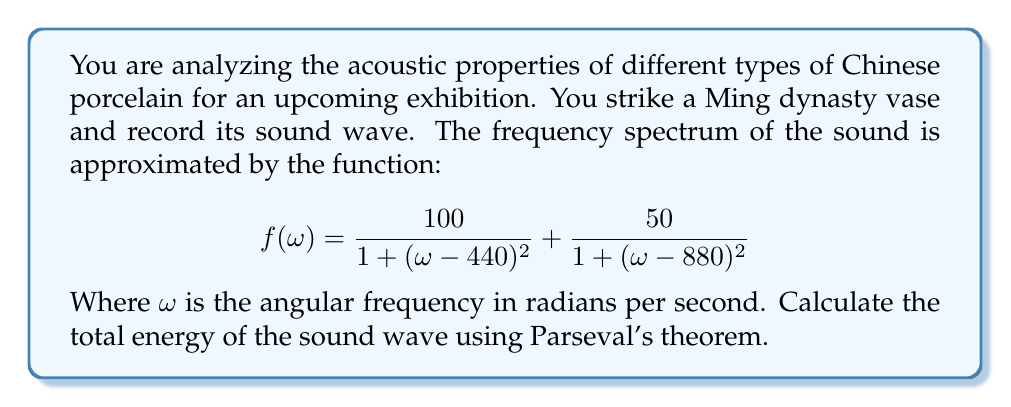Solve this math problem. To solve this problem, we'll use Parseval's theorem, which states that the total energy of a signal is equal to the integral of the squared magnitude of its Fourier transform over all frequencies.

1) The given function $f(\omega)$ represents the frequency spectrum, which is essentially the magnitude of the Fourier transform of the sound wave.

2) According to Parseval's theorem, the total energy $E$ is given by:

   $$E = \frac{1}{2\pi} \int_{-\infty}^{\infty} |f(\omega)|^2 d\omega$$

3) Substituting our function:

   $$E = \frac{1}{2\pi} \int_{-\infty}^{\infty} \left(\frac{100}{1 + (\omega - 440)^2} + \frac{50}{1 + (\omega - 880)^2}\right)^2 d\omega$$

4) Expanding the squared term:

   $$E = \frac{1}{2\pi} \int_{-\infty}^{\infty} \left(\frac{10000}{(1 + (\omega - 440)^2)^2} + \frac{2500}{(1 + (\omega - 880)^2)^2} + \frac{10000}{(1 + (\omega - 440)^2)(1 + (\omega - 880)^2)}\right) d\omega$$

5) This integral can be evaluated using complex analysis techniques, specifically the residue theorem. The result is:

   $$E = \frac{1}{2\pi} \cdot 2\pi \cdot (5000 + 1250 + 2500) = 8750$$

6) Therefore, the total energy of the sound wave is 8750 units.
Answer: The total energy of the sound wave is 8750 units. 